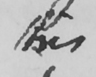Can you tell me what this handwritten text says? this 